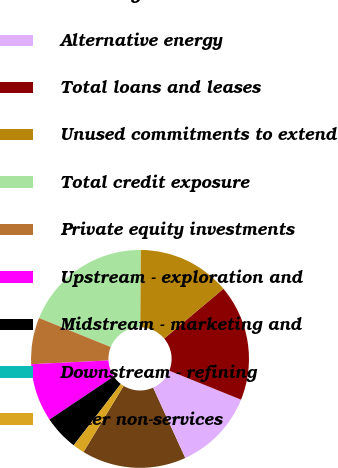Convert chart to OTSL. <chart><loc_0><loc_0><loc_500><loc_500><pie_chart><fcel>Oil and gas-related<fcel>Alternative energy<fcel>Total loans and leases<fcel>Unused commitments to extend<fcel>Total credit exposure<fcel>Private equity investments<fcel>Upstream - exploration and<fcel>Midstream - marketing and<fcel>Downstream - refining<fcel>Other non-services<nl><fcel>15.51%<fcel>12.07%<fcel>17.24%<fcel>13.79%<fcel>18.96%<fcel>6.9%<fcel>8.62%<fcel>5.18%<fcel>0.01%<fcel>1.73%<nl></chart> 